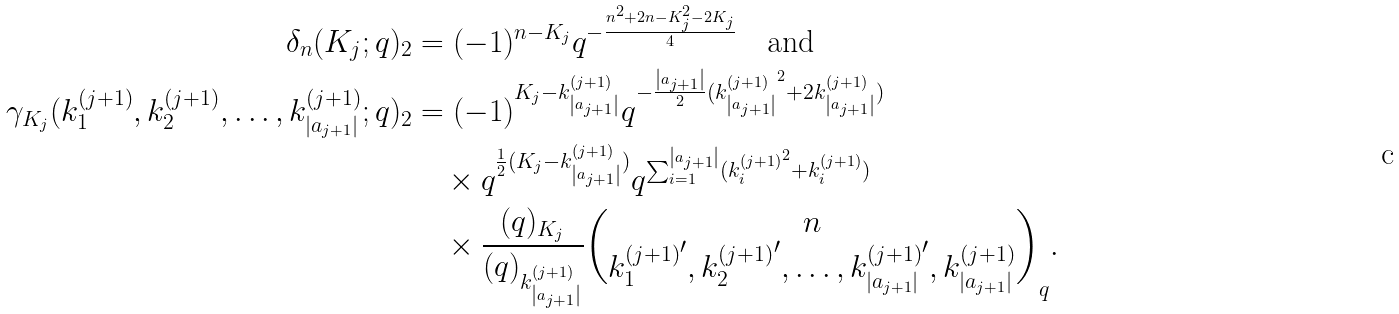Convert formula to latex. <formula><loc_0><loc_0><loc_500><loc_500>\delta _ { n } ( K _ { j } ; q ) _ { 2 } & = ( - 1 ) ^ { n - K _ { j } } q ^ { - \frac { n ^ { 2 } + 2 n - K _ { j } ^ { 2 } - 2 K _ { j } } { 4 } } \quad \text {and} \\ \gamma _ { K _ { j } } ( k _ { 1 } ^ { ( j + 1 ) } , k _ { 2 } ^ { ( j + 1 ) } , \dots , k _ { \left | a _ { j + 1 } \right | } ^ { ( j + 1 ) } ; q ) _ { 2 } & = ( - 1 ) ^ { K _ { j } - k _ { \left | a _ { j + 1 } \right | } ^ { ( j + 1 ) } } q ^ { - \frac { \left | a _ { j + 1 } \right | } { 2 } ( { k _ { \left | a _ { j + 1 } \right | } ^ { ( j + 1 ) } } ^ { 2 } + 2 { k _ { \left | a _ { j + 1 } \right | } ^ { ( j + 1 ) } } ) } \\ & \quad \times q ^ { \frac { 1 } { 2 } ( K _ { j } - k _ { \left | a _ { j + 1 } \right | } ^ { ( j + 1 ) } ) } q ^ { \sum _ { i = 1 } ^ { \left | a _ { j + 1 } \right | } ( { k _ { i } ^ { ( j + 1 ) } } ^ { 2 } + k _ { i } ^ { ( j + 1 ) } ) } \\ & \quad \times \frac { ( q ) _ { K _ { j } } } { ( q ) _ { k _ { \left | a _ { j + 1 } \right | } ^ { ( j + 1 ) } } } { n \choose { k _ { 1 } ^ { ( j + 1 ) } } ^ { \prime } , { k _ { 2 } ^ { ( j + 1 ) } } ^ { \prime } , \dots , { k _ { \left | a _ { j + 1 } \right | } ^ { ( j + 1 ) } } ^ { \prime } , k _ { \left | a _ { j + 1 } \right | } ^ { ( j + 1 ) } } _ { q } .</formula> 